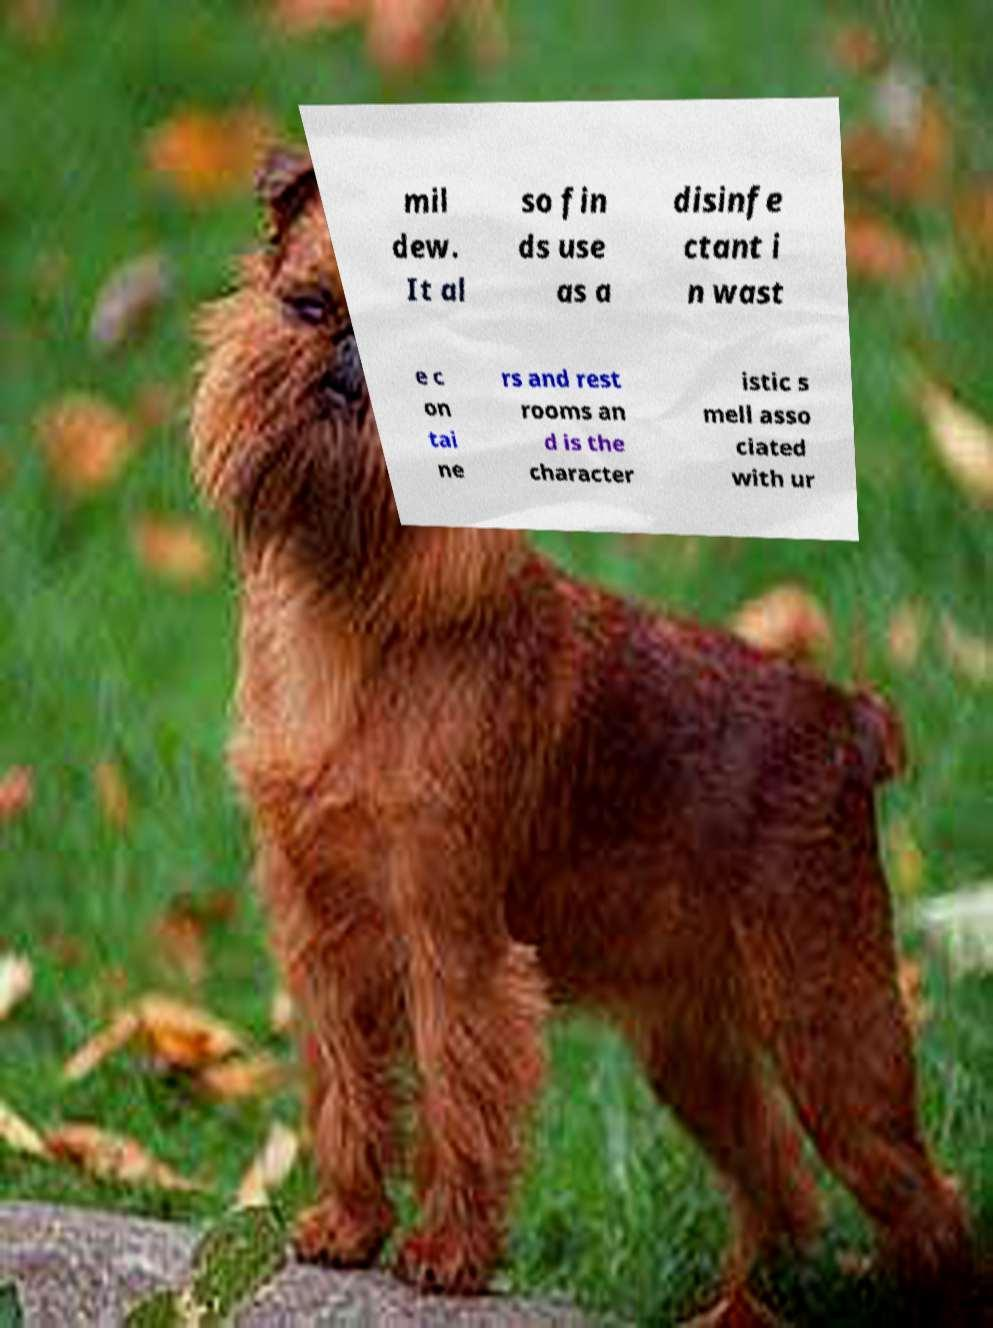Can you read and provide the text displayed in the image?This photo seems to have some interesting text. Can you extract and type it out for me? mil dew. It al so fin ds use as a disinfe ctant i n wast e c on tai ne rs and rest rooms an d is the character istic s mell asso ciated with ur 